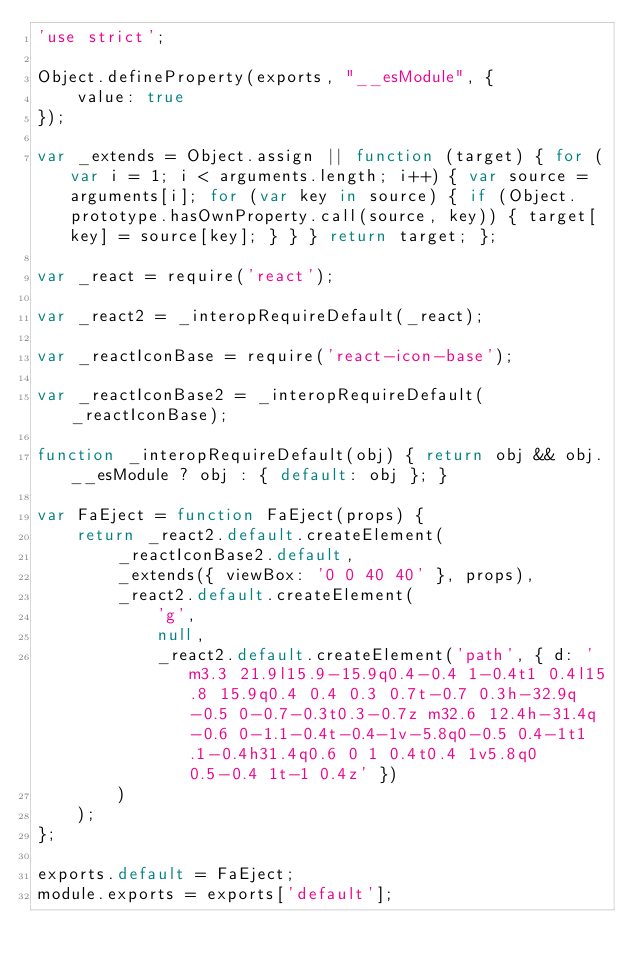Convert code to text. <code><loc_0><loc_0><loc_500><loc_500><_JavaScript_>'use strict';

Object.defineProperty(exports, "__esModule", {
    value: true
});

var _extends = Object.assign || function (target) { for (var i = 1; i < arguments.length; i++) { var source = arguments[i]; for (var key in source) { if (Object.prototype.hasOwnProperty.call(source, key)) { target[key] = source[key]; } } } return target; };

var _react = require('react');

var _react2 = _interopRequireDefault(_react);

var _reactIconBase = require('react-icon-base');

var _reactIconBase2 = _interopRequireDefault(_reactIconBase);

function _interopRequireDefault(obj) { return obj && obj.__esModule ? obj : { default: obj }; }

var FaEject = function FaEject(props) {
    return _react2.default.createElement(
        _reactIconBase2.default,
        _extends({ viewBox: '0 0 40 40' }, props),
        _react2.default.createElement(
            'g',
            null,
            _react2.default.createElement('path', { d: 'm3.3 21.9l15.9-15.9q0.4-0.4 1-0.4t1 0.4l15.8 15.9q0.4 0.4 0.3 0.7t-0.7 0.3h-32.9q-0.5 0-0.7-0.3t0.3-0.7z m32.6 12.4h-31.4q-0.6 0-1.1-0.4t-0.4-1v-5.8q0-0.5 0.4-1t1.1-0.4h31.4q0.6 0 1 0.4t0.4 1v5.8q0 0.5-0.4 1t-1 0.4z' })
        )
    );
};

exports.default = FaEject;
module.exports = exports['default'];</code> 